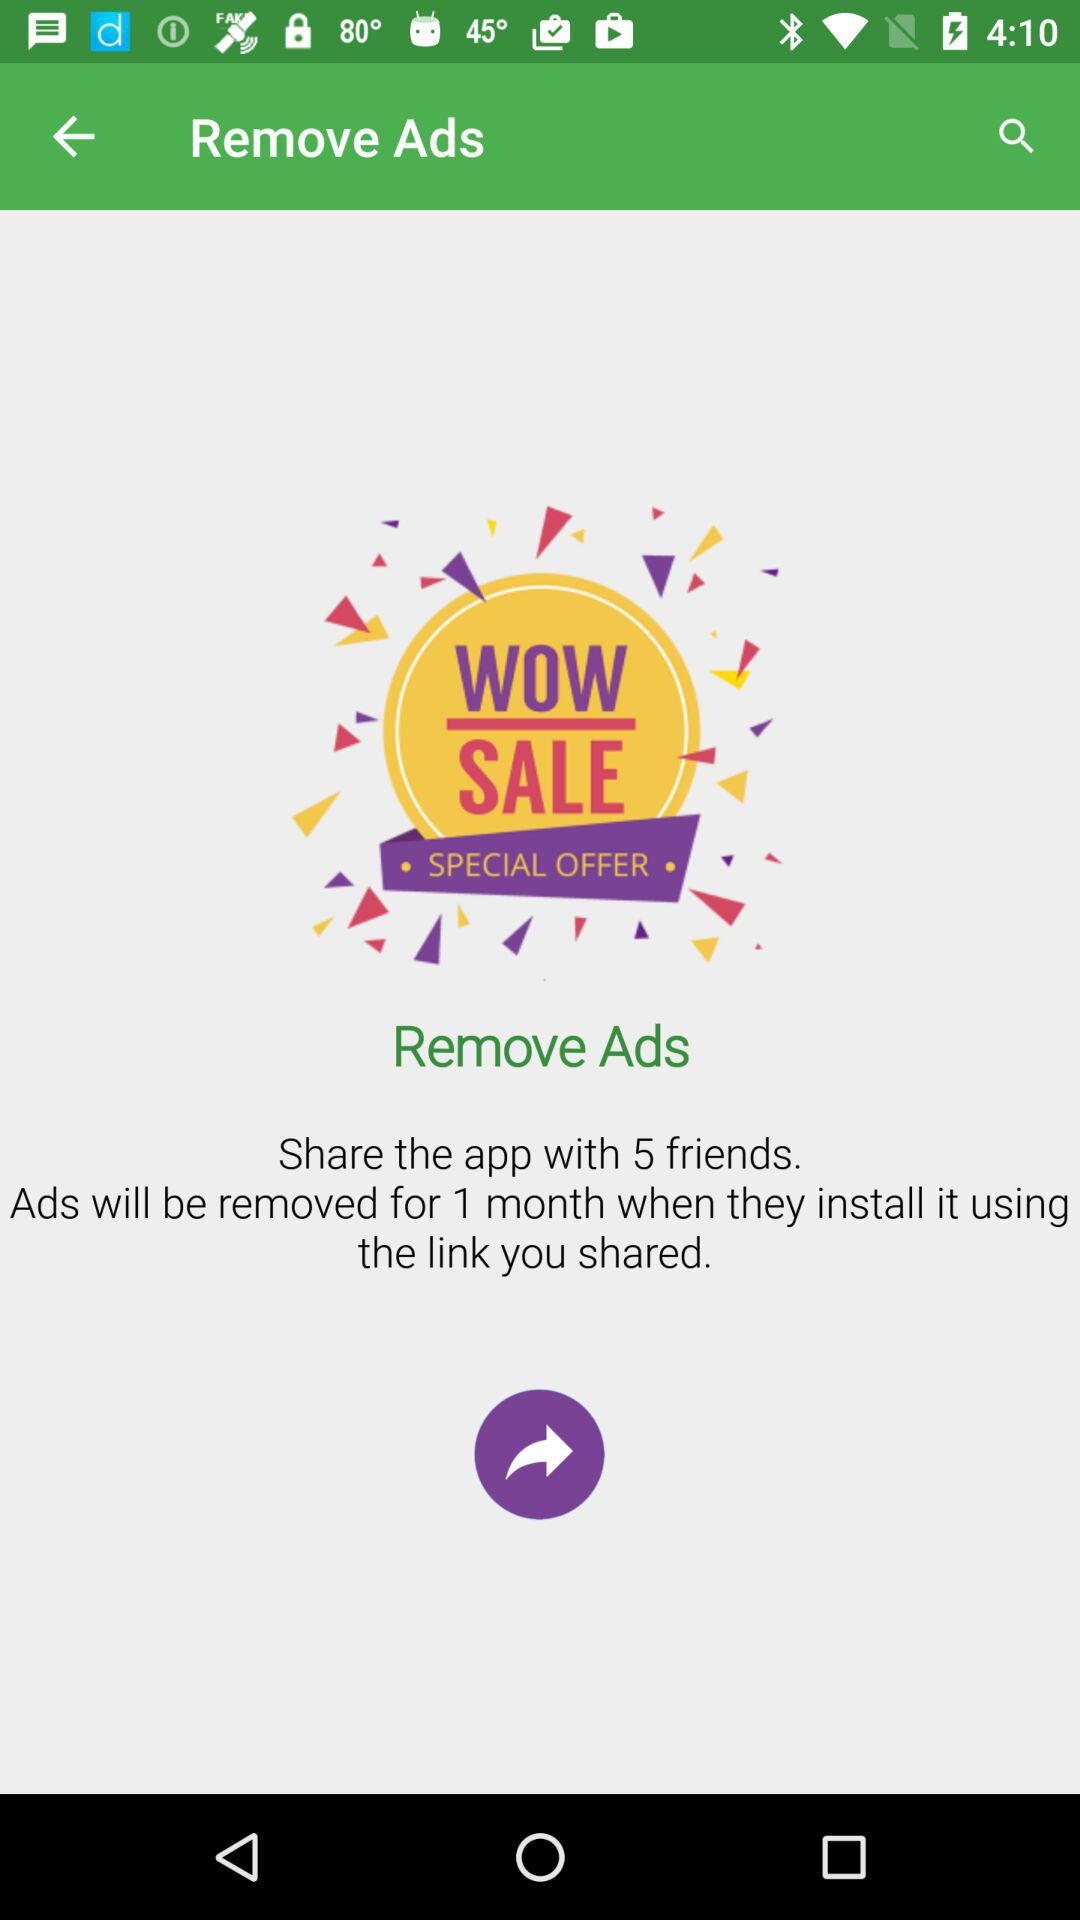How many friends do we need to share the application with in order to remove the advertisement for a month? You need to share the application with 5 friends in order to remove the advertisement for a month. 